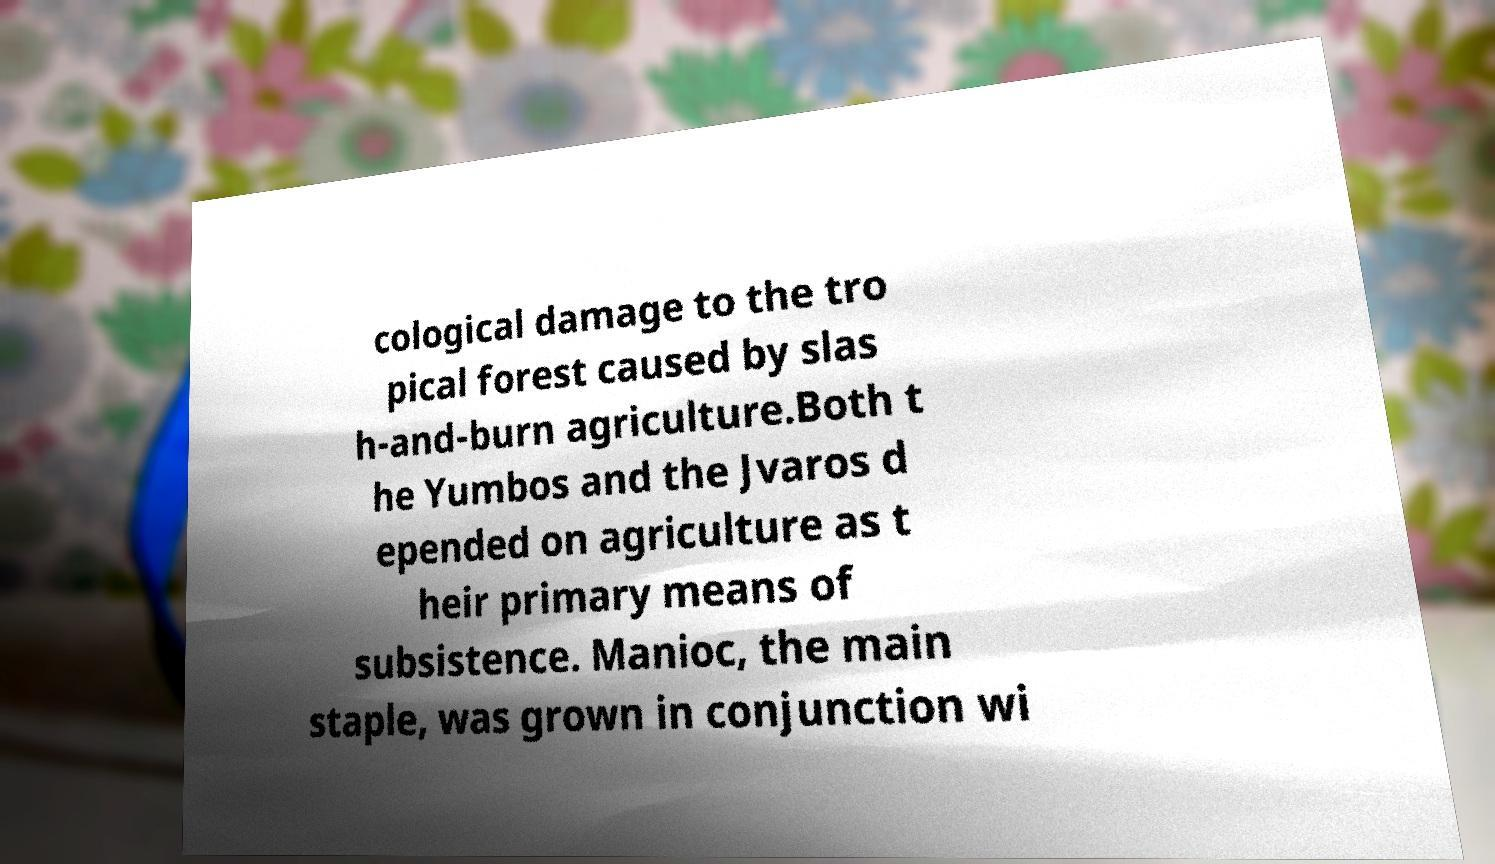I need the written content from this picture converted into text. Can you do that? cological damage to the tro pical forest caused by slas h-and-burn agriculture.Both t he Yumbos and the Jvaros d epended on agriculture as t heir primary means of subsistence. Manioc, the main staple, was grown in conjunction wi 